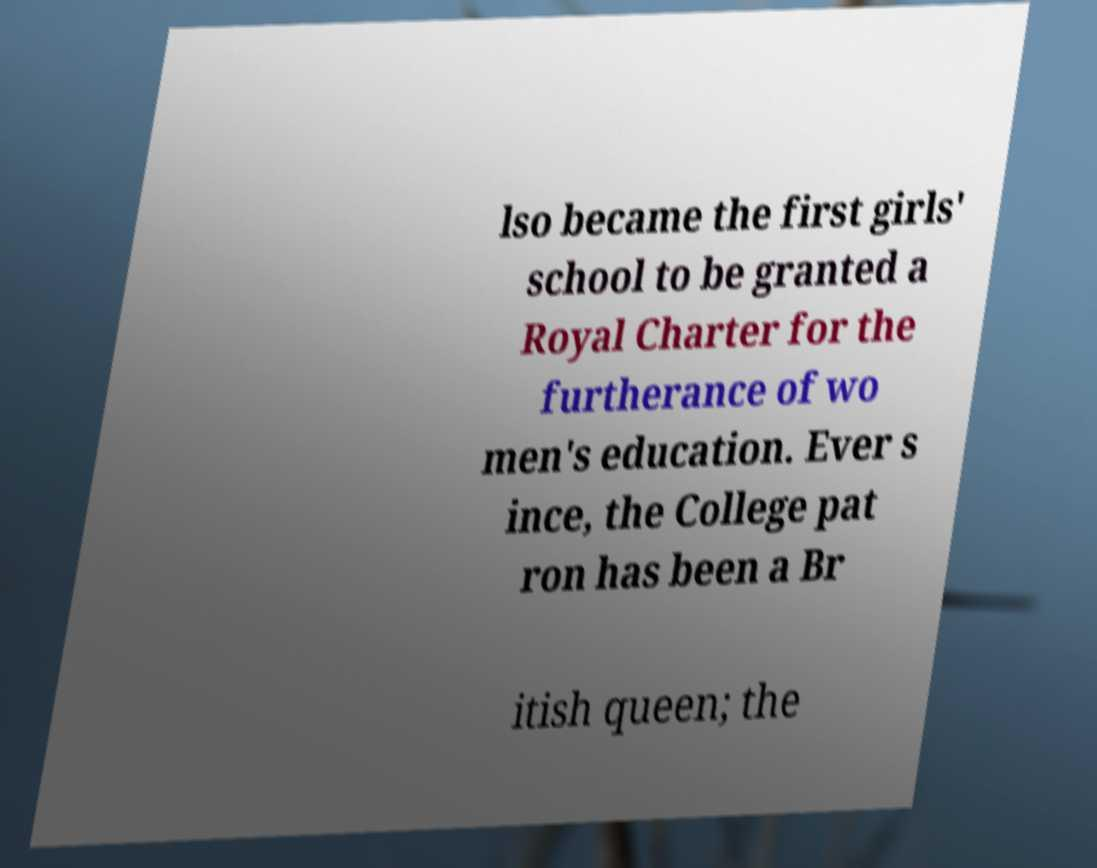For documentation purposes, I need the text within this image transcribed. Could you provide that? lso became the first girls' school to be granted a Royal Charter for the furtherance of wo men's education. Ever s ince, the College pat ron has been a Br itish queen; the 